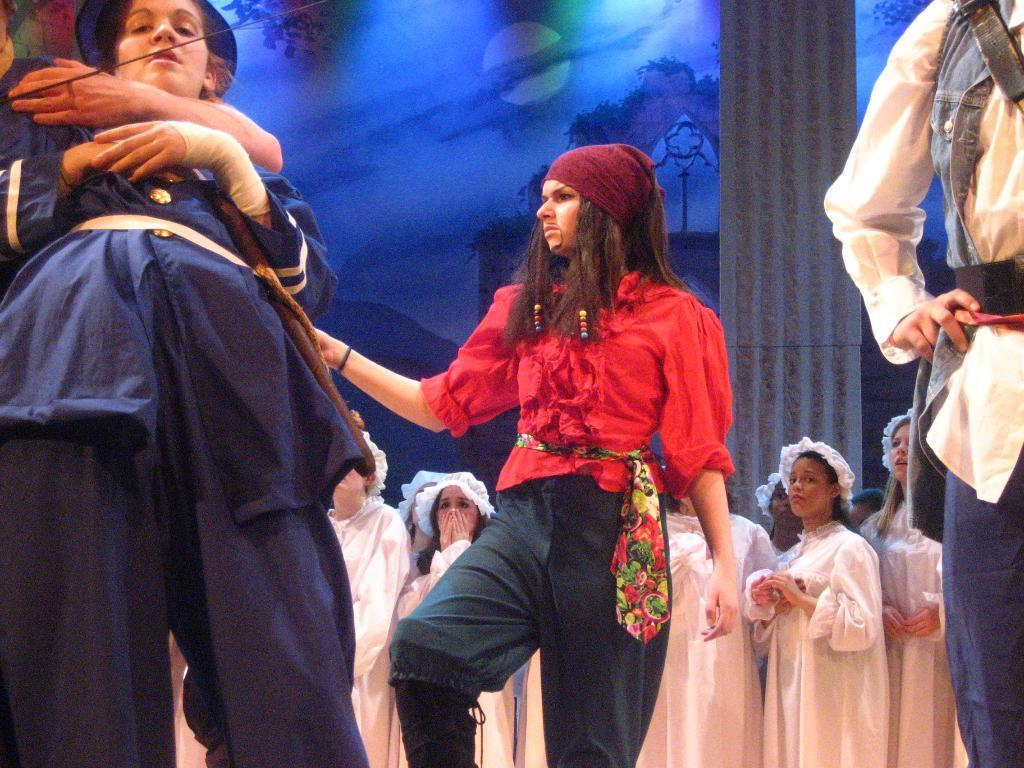What is happening in the image? There are people standing in the image. Where are the people located in the image? The people are in the middle of the image. What can be seen behind the people? There is a banner behind the people. What type of shoes are the judges wearing in the image? There are no judges or shoes present in the image; it only features people standing with a banner behind them. 